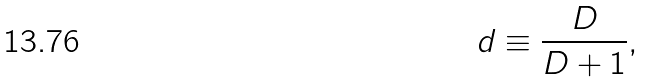<formula> <loc_0><loc_0><loc_500><loc_500>d \equiv \frac { D } { D + 1 } ,</formula> 